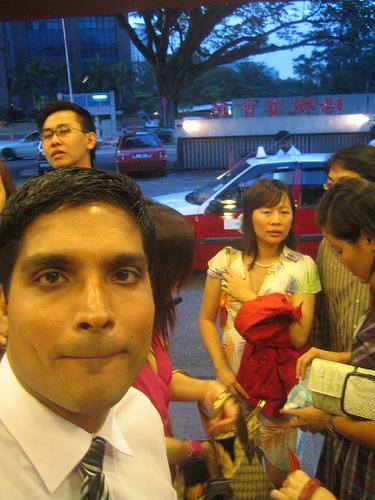What nationality does the man in the foreground appear to be?

Choices:
A) indian
B) french
C) irish
D) german indian 